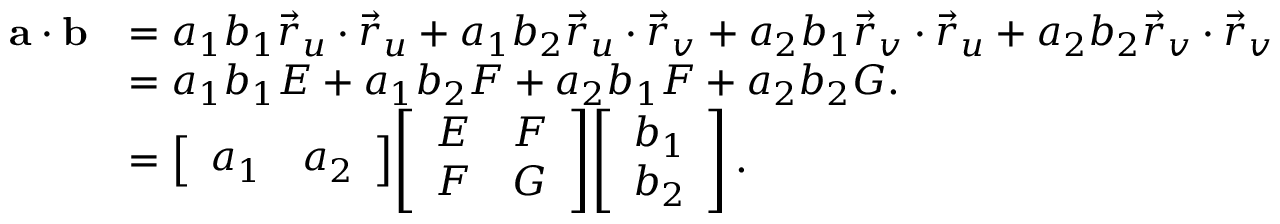Convert formula to latex. <formula><loc_0><loc_0><loc_500><loc_500>{ \begin{array} { r l } { a \cdot b } & { = a _ { 1 } b _ { 1 } { \vec { r } } _ { u } \cdot { \vec { r } } _ { u } + a _ { 1 } b _ { 2 } { \vec { r } } _ { u } \cdot { \vec { r } } _ { v } + a _ { 2 } b _ { 1 } { \vec { r } } _ { v } \cdot { \vec { r } } _ { u } + a _ { 2 } b _ { 2 } { \vec { r } } _ { v } \cdot { \vec { r } } _ { v } } \\ & { = a _ { 1 } b _ { 1 } E + a _ { 1 } b _ { 2 } F + a _ { 2 } b _ { 1 } F + a _ { 2 } b _ { 2 } G . } \\ & { = { \left [ \begin{array} { l l } { a _ { 1 } } & { a _ { 2 } } \end{array} \right ] } { \left [ \begin{array} { l l } { E } & { F } \\ { F } & { G } \end{array} \right ] } { \left [ \begin{array} { l } { b _ { 1 } } \\ { b _ { 2 } } \end{array} \right ] } \, . } \end{array} }</formula> 